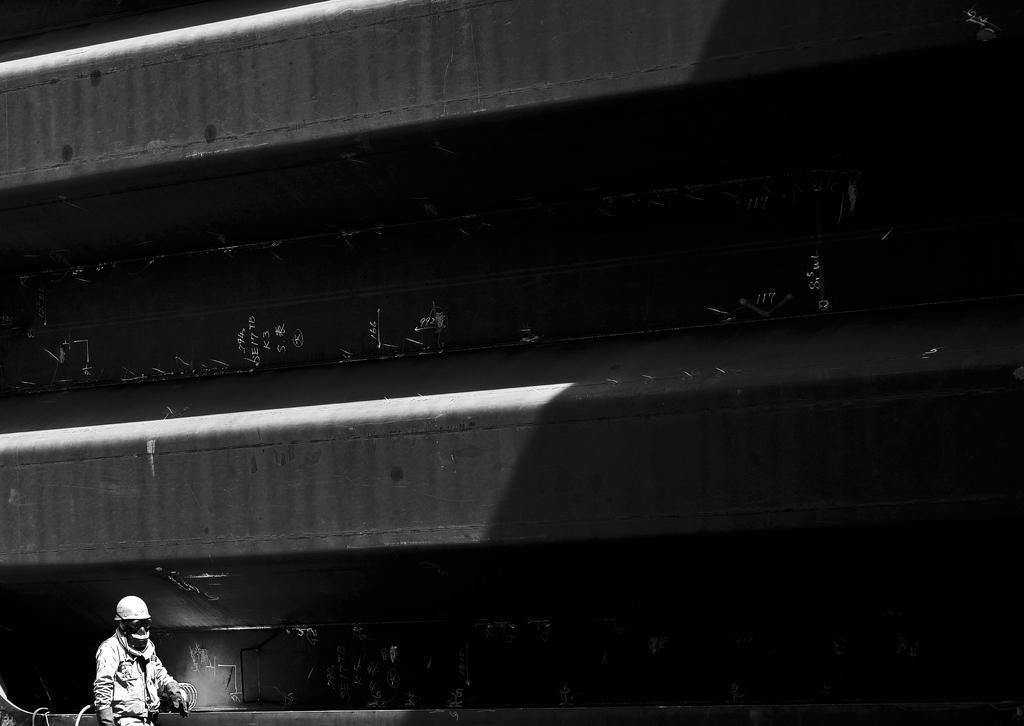Please provide a concise description of this image. In this image in the middle there might be a bridge, in front of the bridge there is a person wearing a helmet visible at the bottom. 